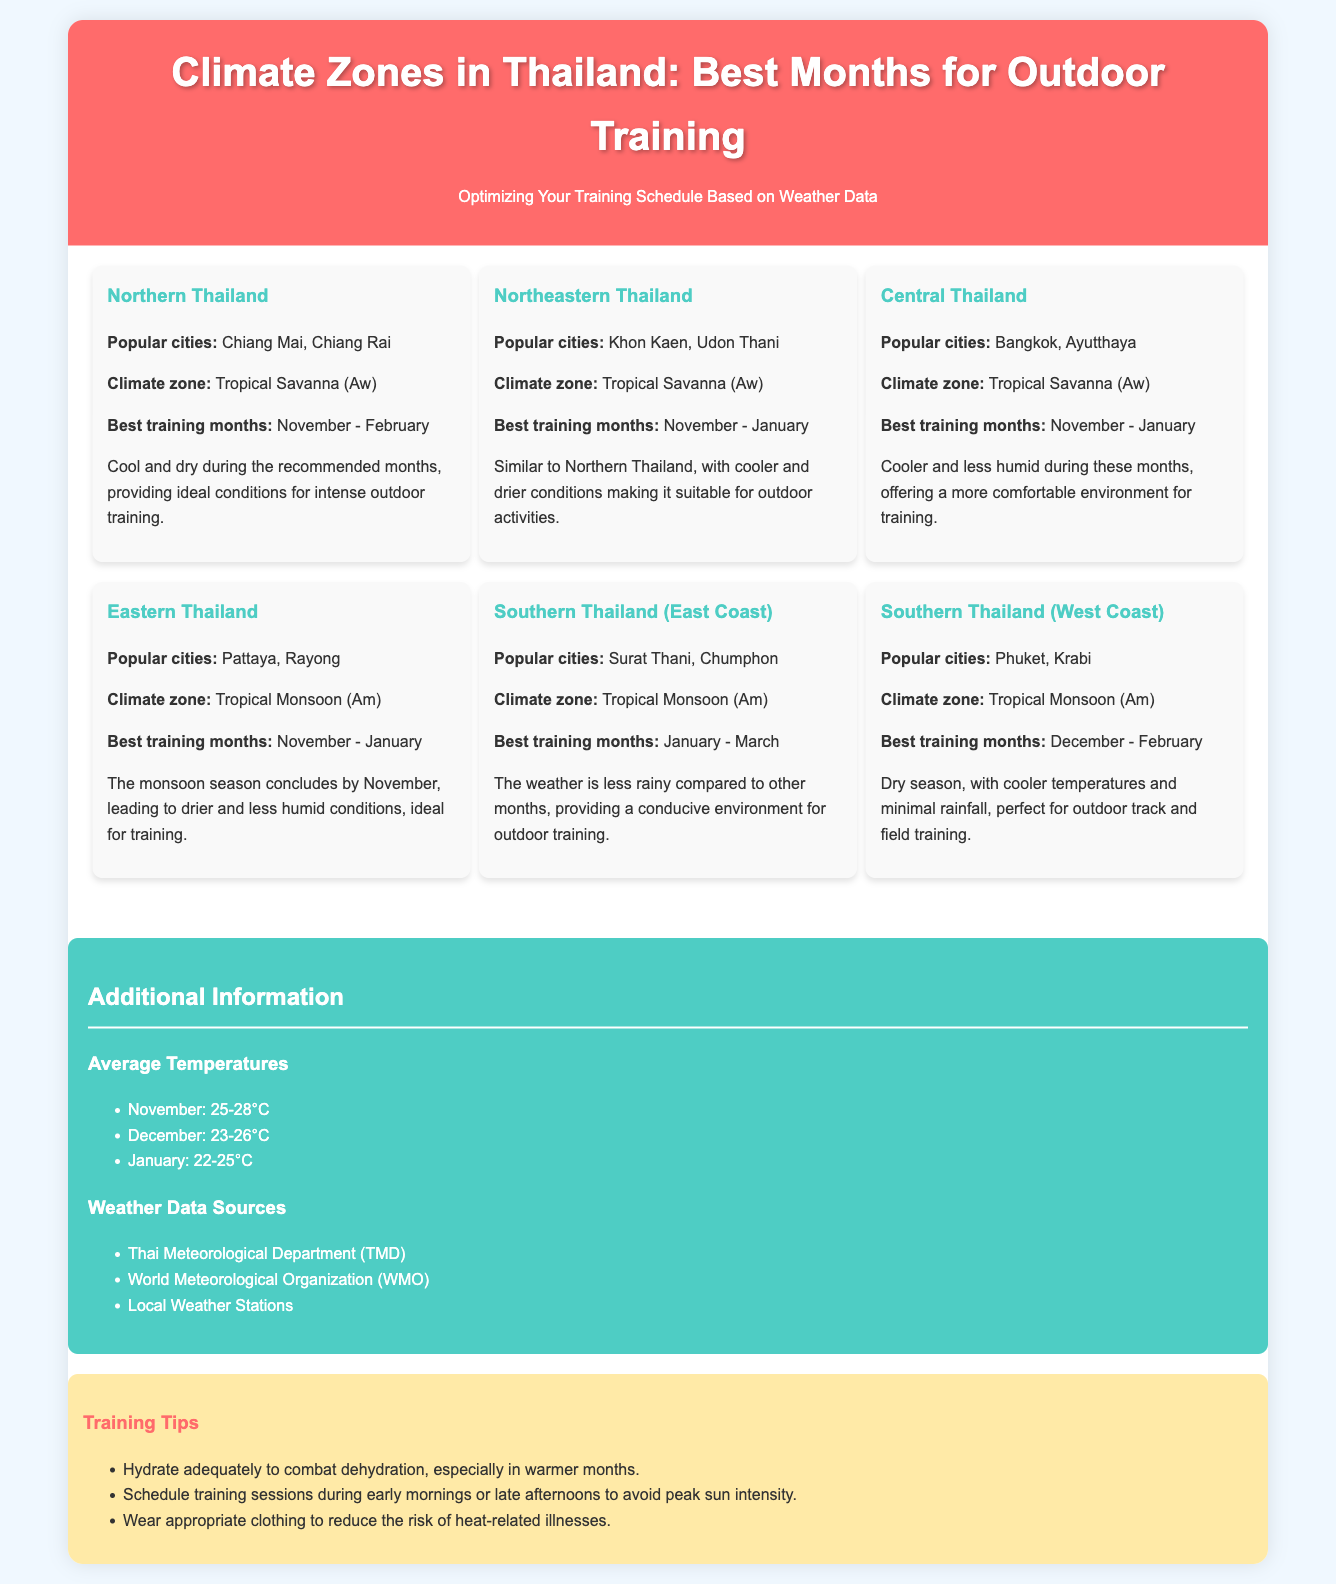what is the best training month for Northern Thailand? The best training months for Northern Thailand are detailed in the region section as November to February.
Answer: November - February which climate zone is Central Thailand categorized under? The climate zone for Central Thailand is specified as Tropical Savanna (Aw).
Answer: Tropical Savanna (Aw) what is the average temperature range in January? The document lists the average temperature in January as between 22-25°C.
Answer: 22-25°C which region has the best training months from January to March? The region listed with this timeframe for the best training months is Southern Thailand (East Coast).
Answer: Southern Thailand (East Coast) name one popular city in Northeastern Thailand. A popular city in Northeastern Thailand mentioned in the document is Khon Kaen.
Answer: Khon Kaen what is a key training tip provided in the infographic? One of the training tips emphasizes the need to hydrate adequately to combat dehydration.
Answer: Hydrate adequately which region experiences drier conditions after November? The document states that the Eastern Thailand region sees drier conditions after November.
Answer: Eastern Thailand how many regions are outlined in the infographic? The infographic outlines a total of six regions for training based on climate conditions.
Answer: Six regions 